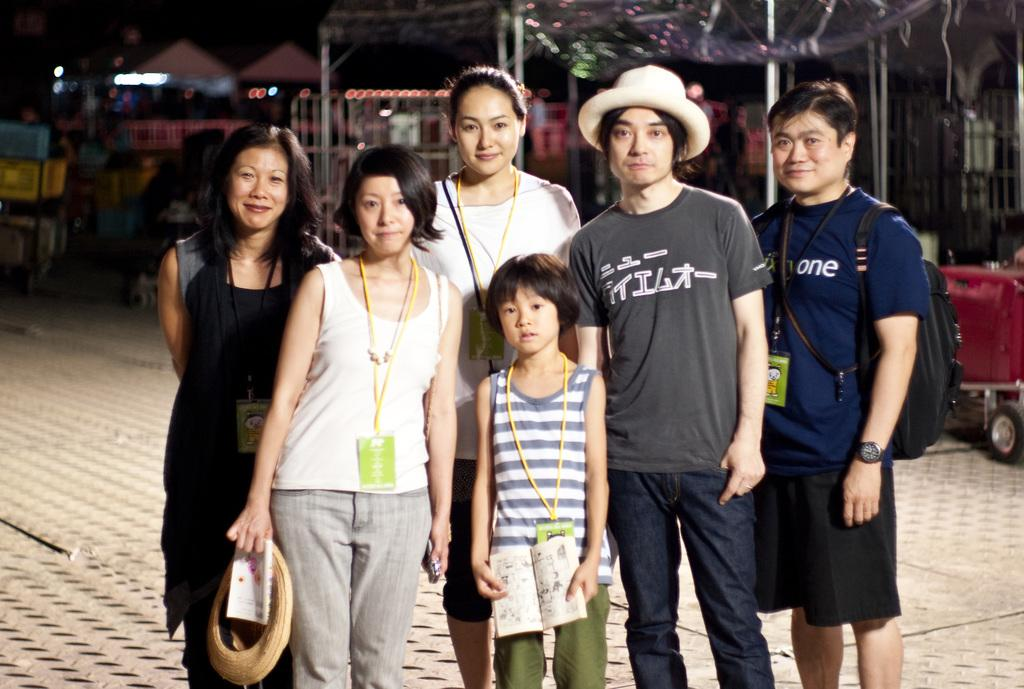What are the people in the image doing? The people in the image are standing on the ground. What can be seen in the background of the image? There are lights visible in the background of the image. How many noses can be seen on the people in the image? There is no information about the people's noses in the image, so it cannot be determined. 